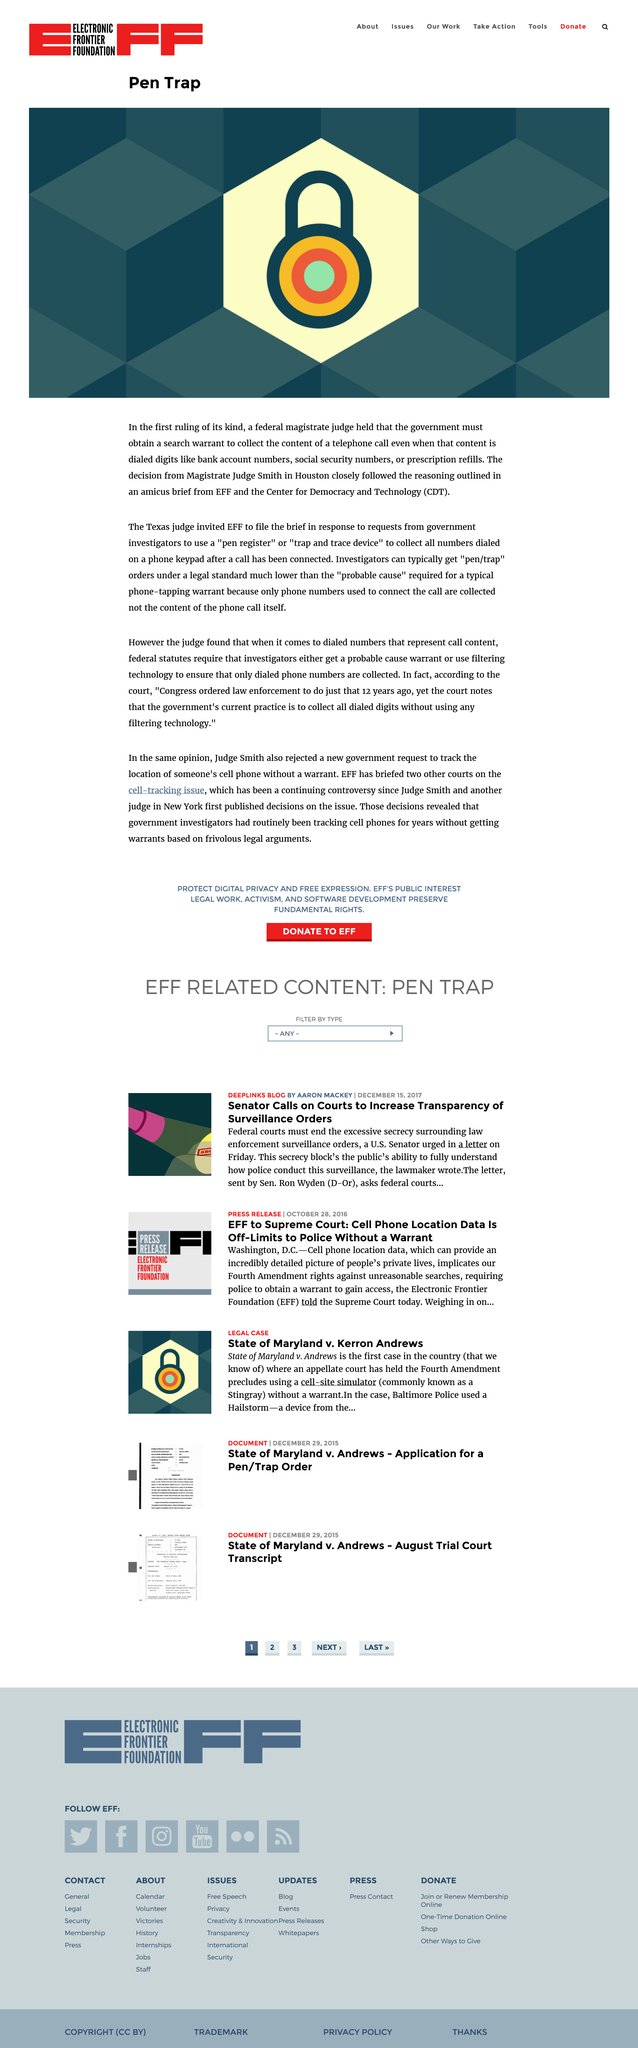Outline some significant characteristics in this image. The acronym CDT stands for the Center for Democracy and Technology, which is a well-known organization dedicated to promoting democracy and protecting civil liberties in the digital age. This ruling was made in the city of Houston, in the state of Texas. The ruling that the government must obtain a search warrant was made by Magistrate Judge Smith. 